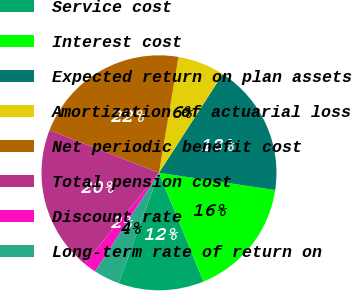Convert chart. <chart><loc_0><loc_0><loc_500><loc_500><pie_chart><fcel>Service cost<fcel>Interest cost<fcel>Expected return on plan assets<fcel>Amortization of actuarial loss<fcel>Net periodic benefit cost<fcel>Total pension cost<fcel>Discount rate<fcel>Long-term rate of return on<nl><fcel>11.76%<fcel>16.47%<fcel>18.22%<fcel>6.47%<fcel>21.74%<fcel>19.98%<fcel>1.8%<fcel>3.56%<nl></chart> 